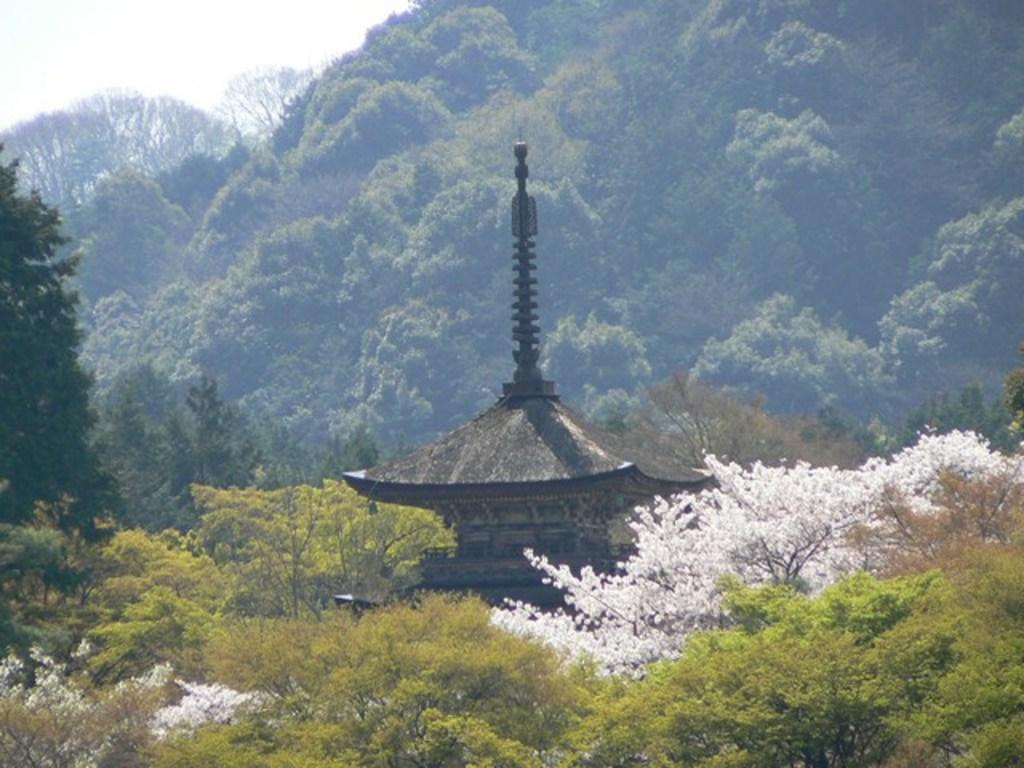What type of structure is present in the image? There is an ancient building in the image. What other natural elements can be seen in the image? There are trees in the image. What is visible in the background of the image? There is a mountain and the sky in the background of the image. Where are the shoes placed in the image? There are no shoes present in the image. What type of kettle can be seen boiling water in the image? There is no kettle present in the image. 